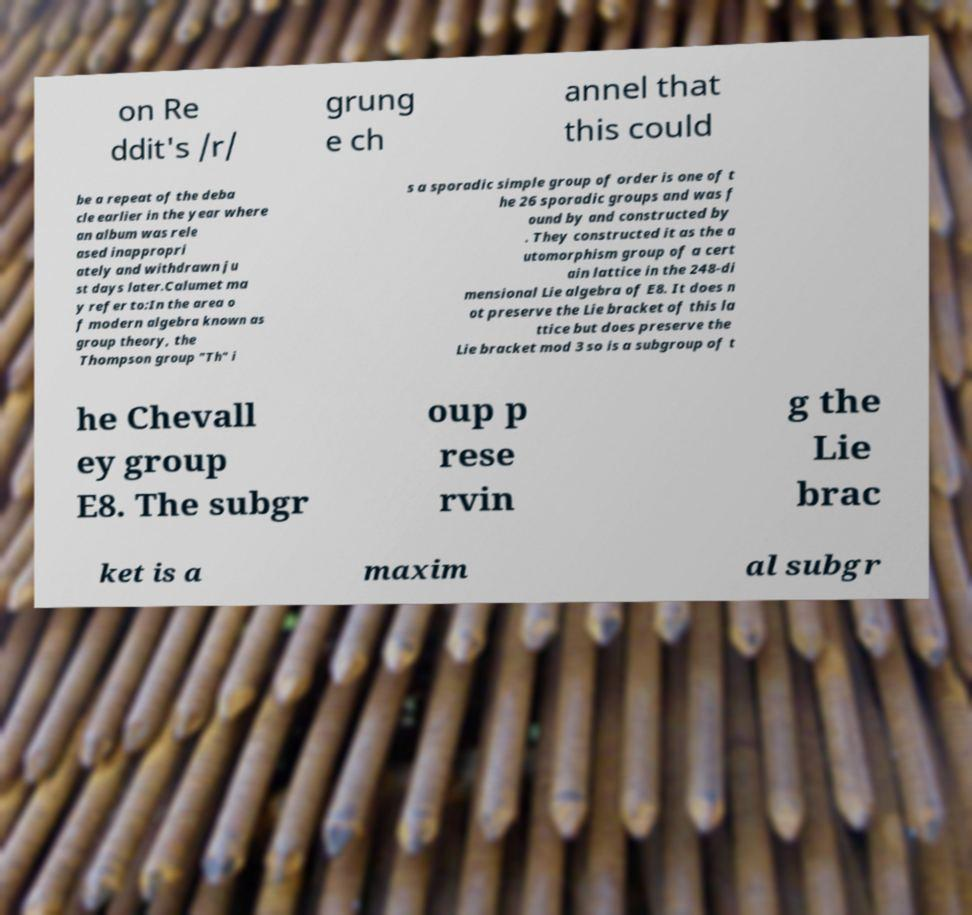Can you read and provide the text displayed in the image?This photo seems to have some interesting text. Can you extract and type it out for me? on Re ddit's /r/ grung e ch annel that this could be a repeat of the deba cle earlier in the year where an album was rele ased inappropri ately and withdrawn ju st days later.Calumet ma y refer to:In the area o f modern algebra known as group theory, the Thompson group "Th" i s a sporadic simple group of order is one of t he 26 sporadic groups and was f ound by and constructed by . They constructed it as the a utomorphism group of a cert ain lattice in the 248-di mensional Lie algebra of E8. It does n ot preserve the Lie bracket of this la ttice but does preserve the Lie bracket mod 3 so is a subgroup of t he Chevall ey group E8. The subgr oup p rese rvin g the Lie brac ket is a maxim al subgr 